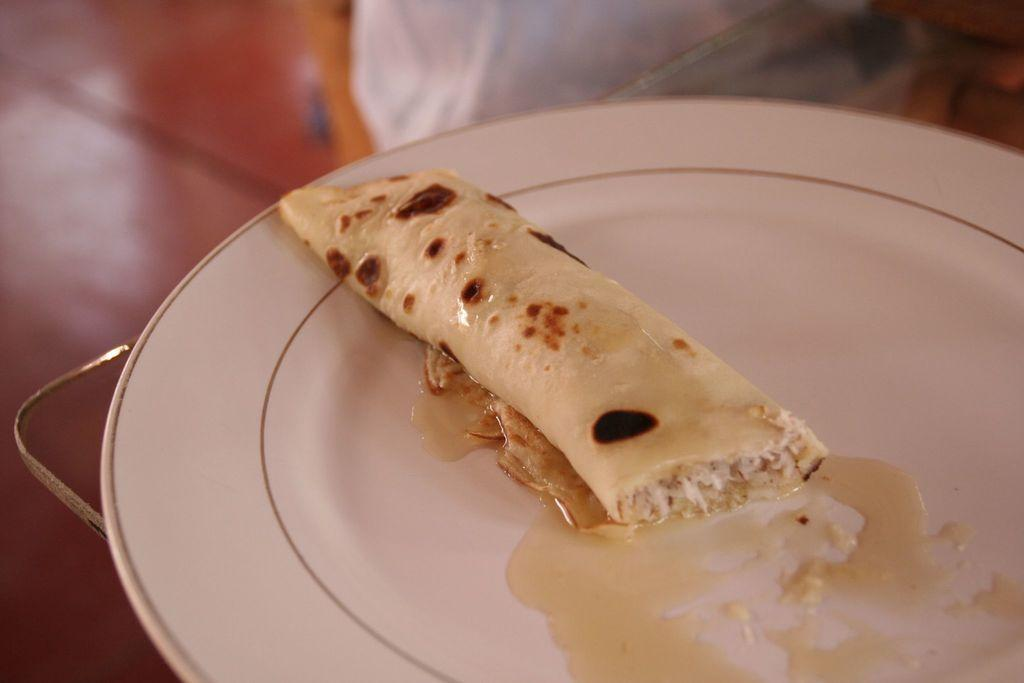What is the main subject of the image? There is a food item in the image. How is the food item presented? The food item is on a plate. Is there any other object supporting the plate? Yes, the plate is on a glass object. Can you describe the background of the image? The background of the image is blurred. What type of jelly can be seen in the image? There is no jelly present in the image. What view can be seen through the window in the image? There is no window present in the image. 